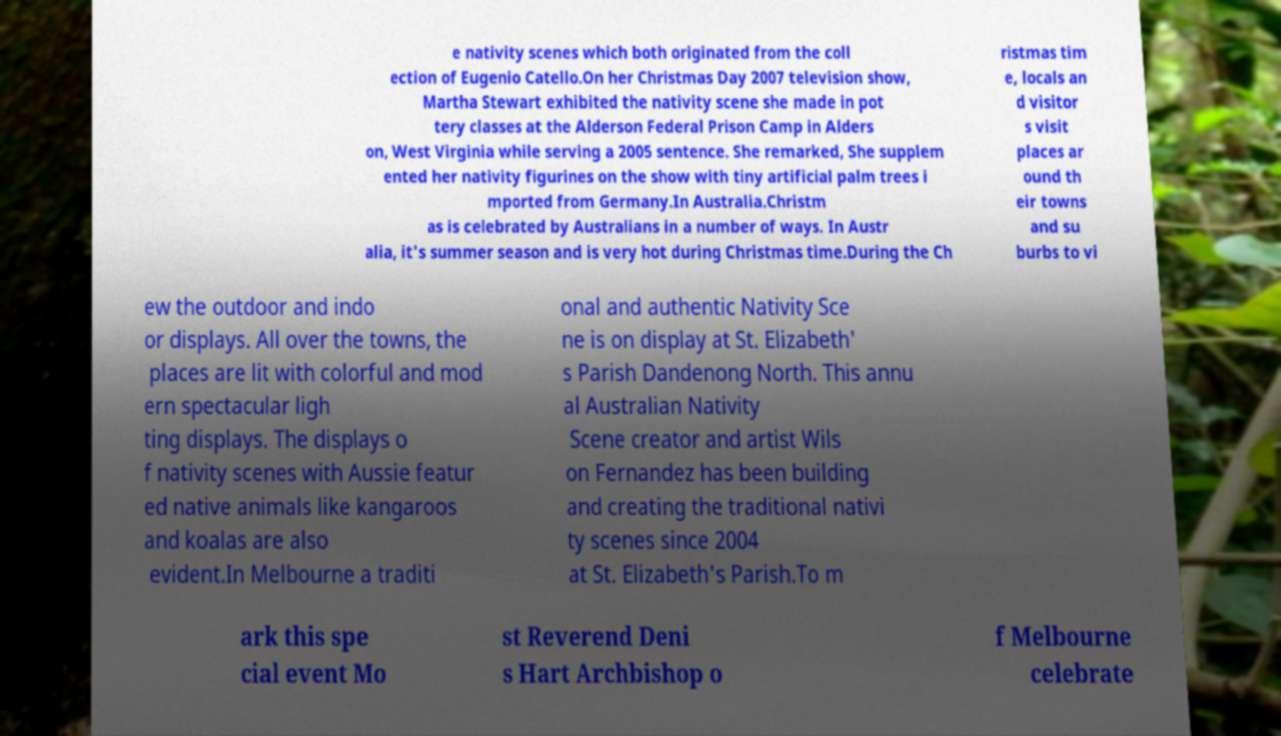Could you extract and type out the text from this image? e nativity scenes which both originated from the coll ection of Eugenio Catello.On her Christmas Day 2007 television show, Martha Stewart exhibited the nativity scene she made in pot tery classes at the Alderson Federal Prison Camp in Alders on, West Virginia while serving a 2005 sentence. She remarked, She supplem ented her nativity figurines on the show with tiny artificial palm trees i mported from Germany.In Australia.Christm as is celebrated by Australians in a number of ways. In Austr alia, it's summer season and is very hot during Christmas time.During the Ch ristmas tim e, locals an d visitor s visit places ar ound th eir towns and su burbs to vi ew the outdoor and indo or displays. All over the towns, the places are lit with colorful and mod ern spectacular ligh ting displays. The displays o f nativity scenes with Aussie featur ed native animals like kangaroos and koalas are also evident.In Melbourne a traditi onal and authentic Nativity Sce ne is on display at St. Elizabeth' s Parish Dandenong North. This annu al Australian Nativity Scene creator and artist Wils on Fernandez has been building and creating the traditional nativi ty scenes since 2004 at St. Elizabeth's Parish.To m ark this spe cial event Mo st Reverend Deni s Hart Archbishop o f Melbourne celebrate 